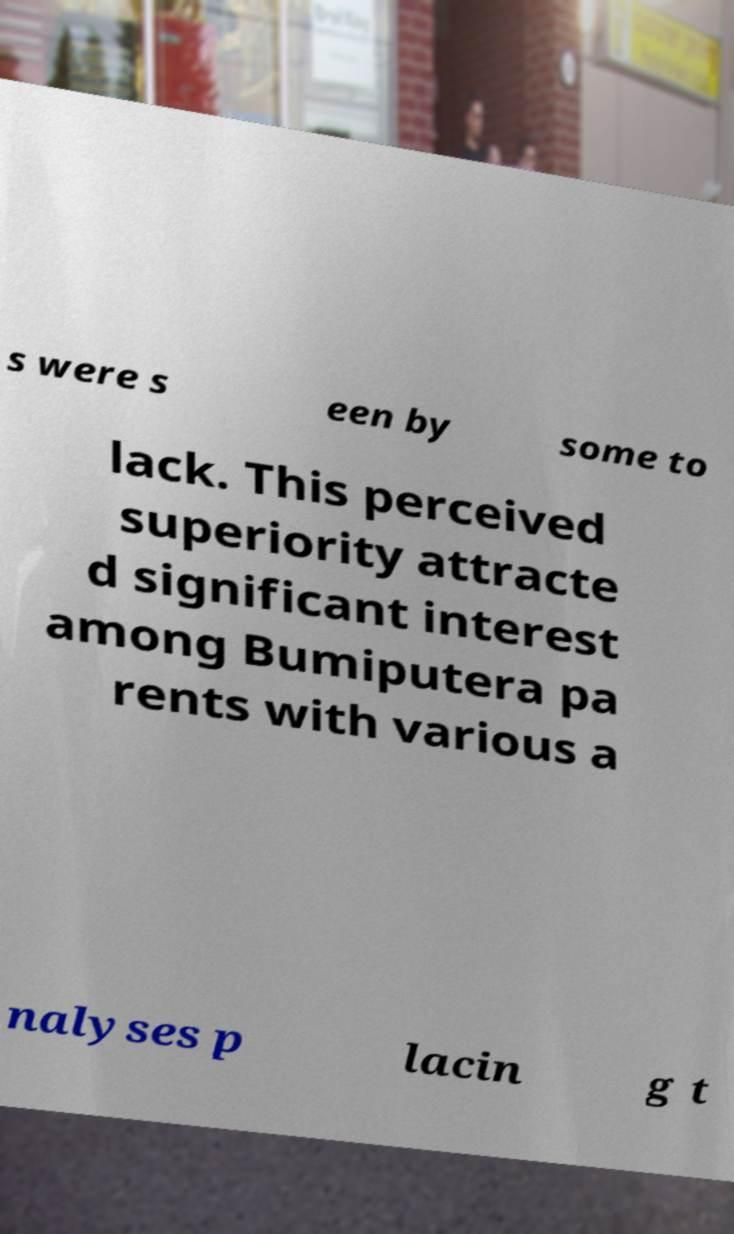Can you read and provide the text displayed in the image?This photo seems to have some interesting text. Can you extract and type it out for me? s were s een by some to lack. This perceived superiority attracte d significant interest among Bumiputera pa rents with various a nalyses p lacin g t 